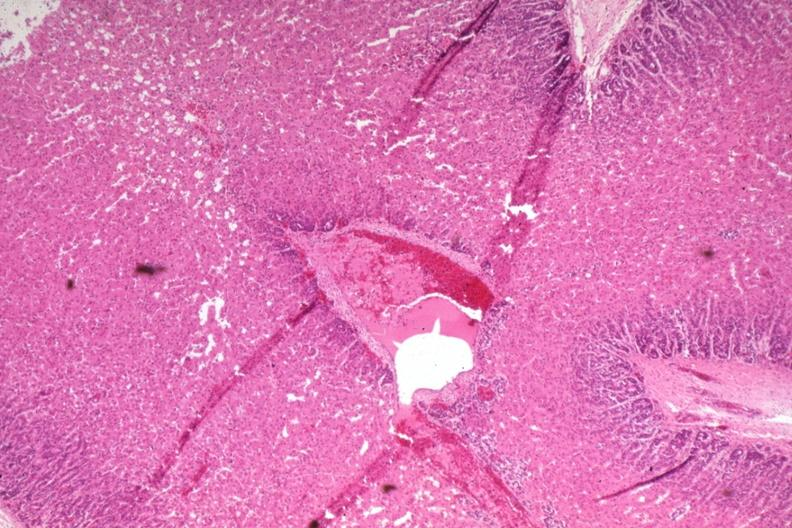does quite good liver show wide fetal zone 2 days old?
Answer the question using a single word or phrase. No 